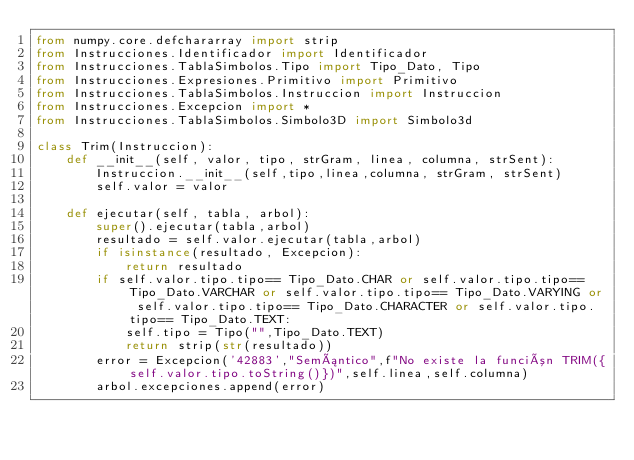<code> <loc_0><loc_0><loc_500><loc_500><_Python_>from numpy.core.defchararray import strip
from Instrucciones.Identificador import Identificador
from Instrucciones.TablaSimbolos.Tipo import Tipo_Dato, Tipo
from Instrucciones.Expresiones.Primitivo import Primitivo
from Instrucciones.TablaSimbolos.Instruccion import Instruccion
from Instrucciones.Excepcion import *
from Instrucciones.TablaSimbolos.Simbolo3D import Simbolo3d

class Trim(Instruccion):
    def __init__(self, valor, tipo, strGram, linea, columna, strSent):
        Instruccion.__init__(self,tipo,linea,columna, strGram, strSent)
        self.valor = valor

    def ejecutar(self, tabla, arbol):
        super().ejecutar(tabla,arbol)
        resultado = self.valor.ejecutar(tabla,arbol)
        if isinstance(resultado, Excepcion):
            return resultado
        if self.valor.tipo.tipo== Tipo_Dato.CHAR or self.valor.tipo.tipo== Tipo_Dato.VARCHAR or self.valor.tipo.tipo== Tipo_Dato.VARYING or self.valor.tipo.tipo== Tipo_Dato.CHARACTER or self.valor.tipo.tipo== Tipo_Dato.TEXT:
            self.tipo = Tipo("",Tipo_Dato.TEXT)
            return strip(str(resultado)) 
        error = Excepcion('42883',"Semántico",f"No existe la función TRIM({self.valor.tipo.toString()})",self.linea,self.columna)
        arbol.excepciones.append(error)</code> 